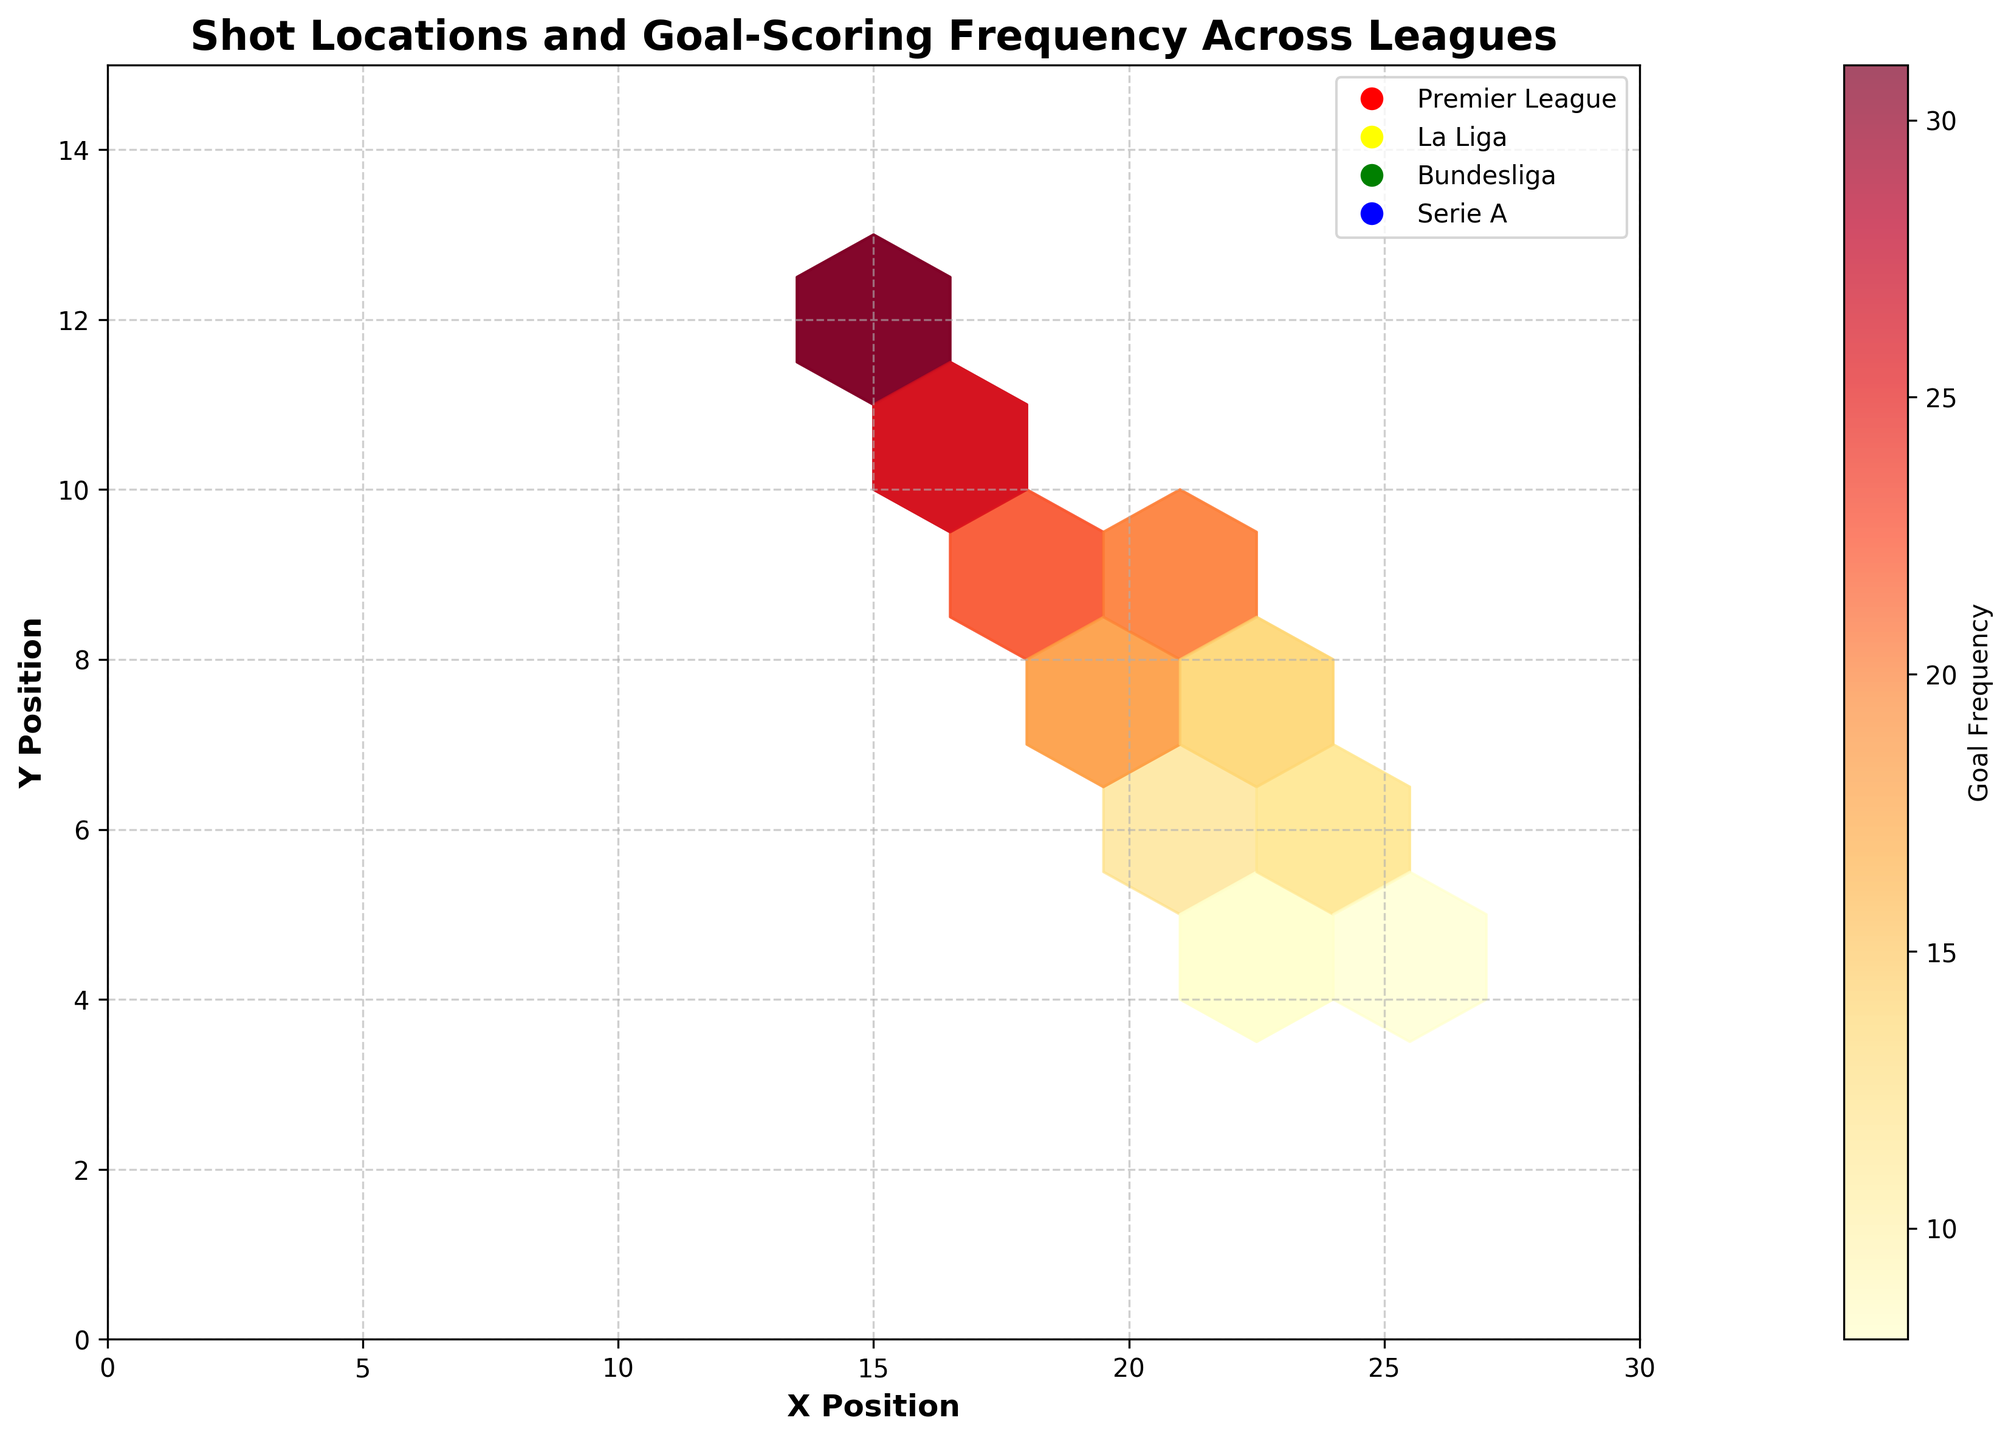What is the title of the figure? The title is usually the largest text at the top of the figure that describes what the figure is about.
Answer: Shot Locations and Goal-Scoring Frequency Across Leagues What color represents the Premier League? Each league is represented by a different color in the plot. The Premier League is labeled in the legend.
Answer: Red What are the x and y labels of the plot? The labels for the x and y axes of the plot give context to the data points' coordinates.
Answer: X Position, Y Position What is the range for the X and Y positions in the plot? The range can be seen by looking at the axis ticks and limits.
Answer: 0-30 for X, 0-15 for Y What does the color intensity in the hexagons represent? The color intensity is often linked to the value of the third dimension in a hexbin plot, explained by the color bar on the side.
Answer: Goal Frequency Which league has the shot location with the highest goal frequency? By comparing the color intensity in the plot and referring to the legend to identify the corresponding league, we can find the highest frequency.
Answer: Serie A What is the goal frequency for the shot located at (18, 10) in the Premier League? Locate the specific hexagon for (18, 10) and refer to the color intensity or the legend if the exact number is provided.
Answer: 25 Compare the goal frequencies of shots at (15, 12) in the Premier League and Bundesliga. Which is higher? By locating and comparing the color intensities or referring to specific frequency values if provided.
Answer: Premier League Which league has the most evenly distributed shot locations and goal frequencies? Analyzing how spread out the hexagons and their frequencies are for each league can help in determining this.
Answer: La Liga What's the average goal frequency for shots in the (20, 9) location across the leagues? Sum the goal frequencies for the (20, 9) location from each league and divide by the number of leagues. Premier League: 22, La Liga: 19, Bundesliga: 21, Serie A: 20. Average = (22+19+21+20)/4 = 20.5
Answer: 20.5 